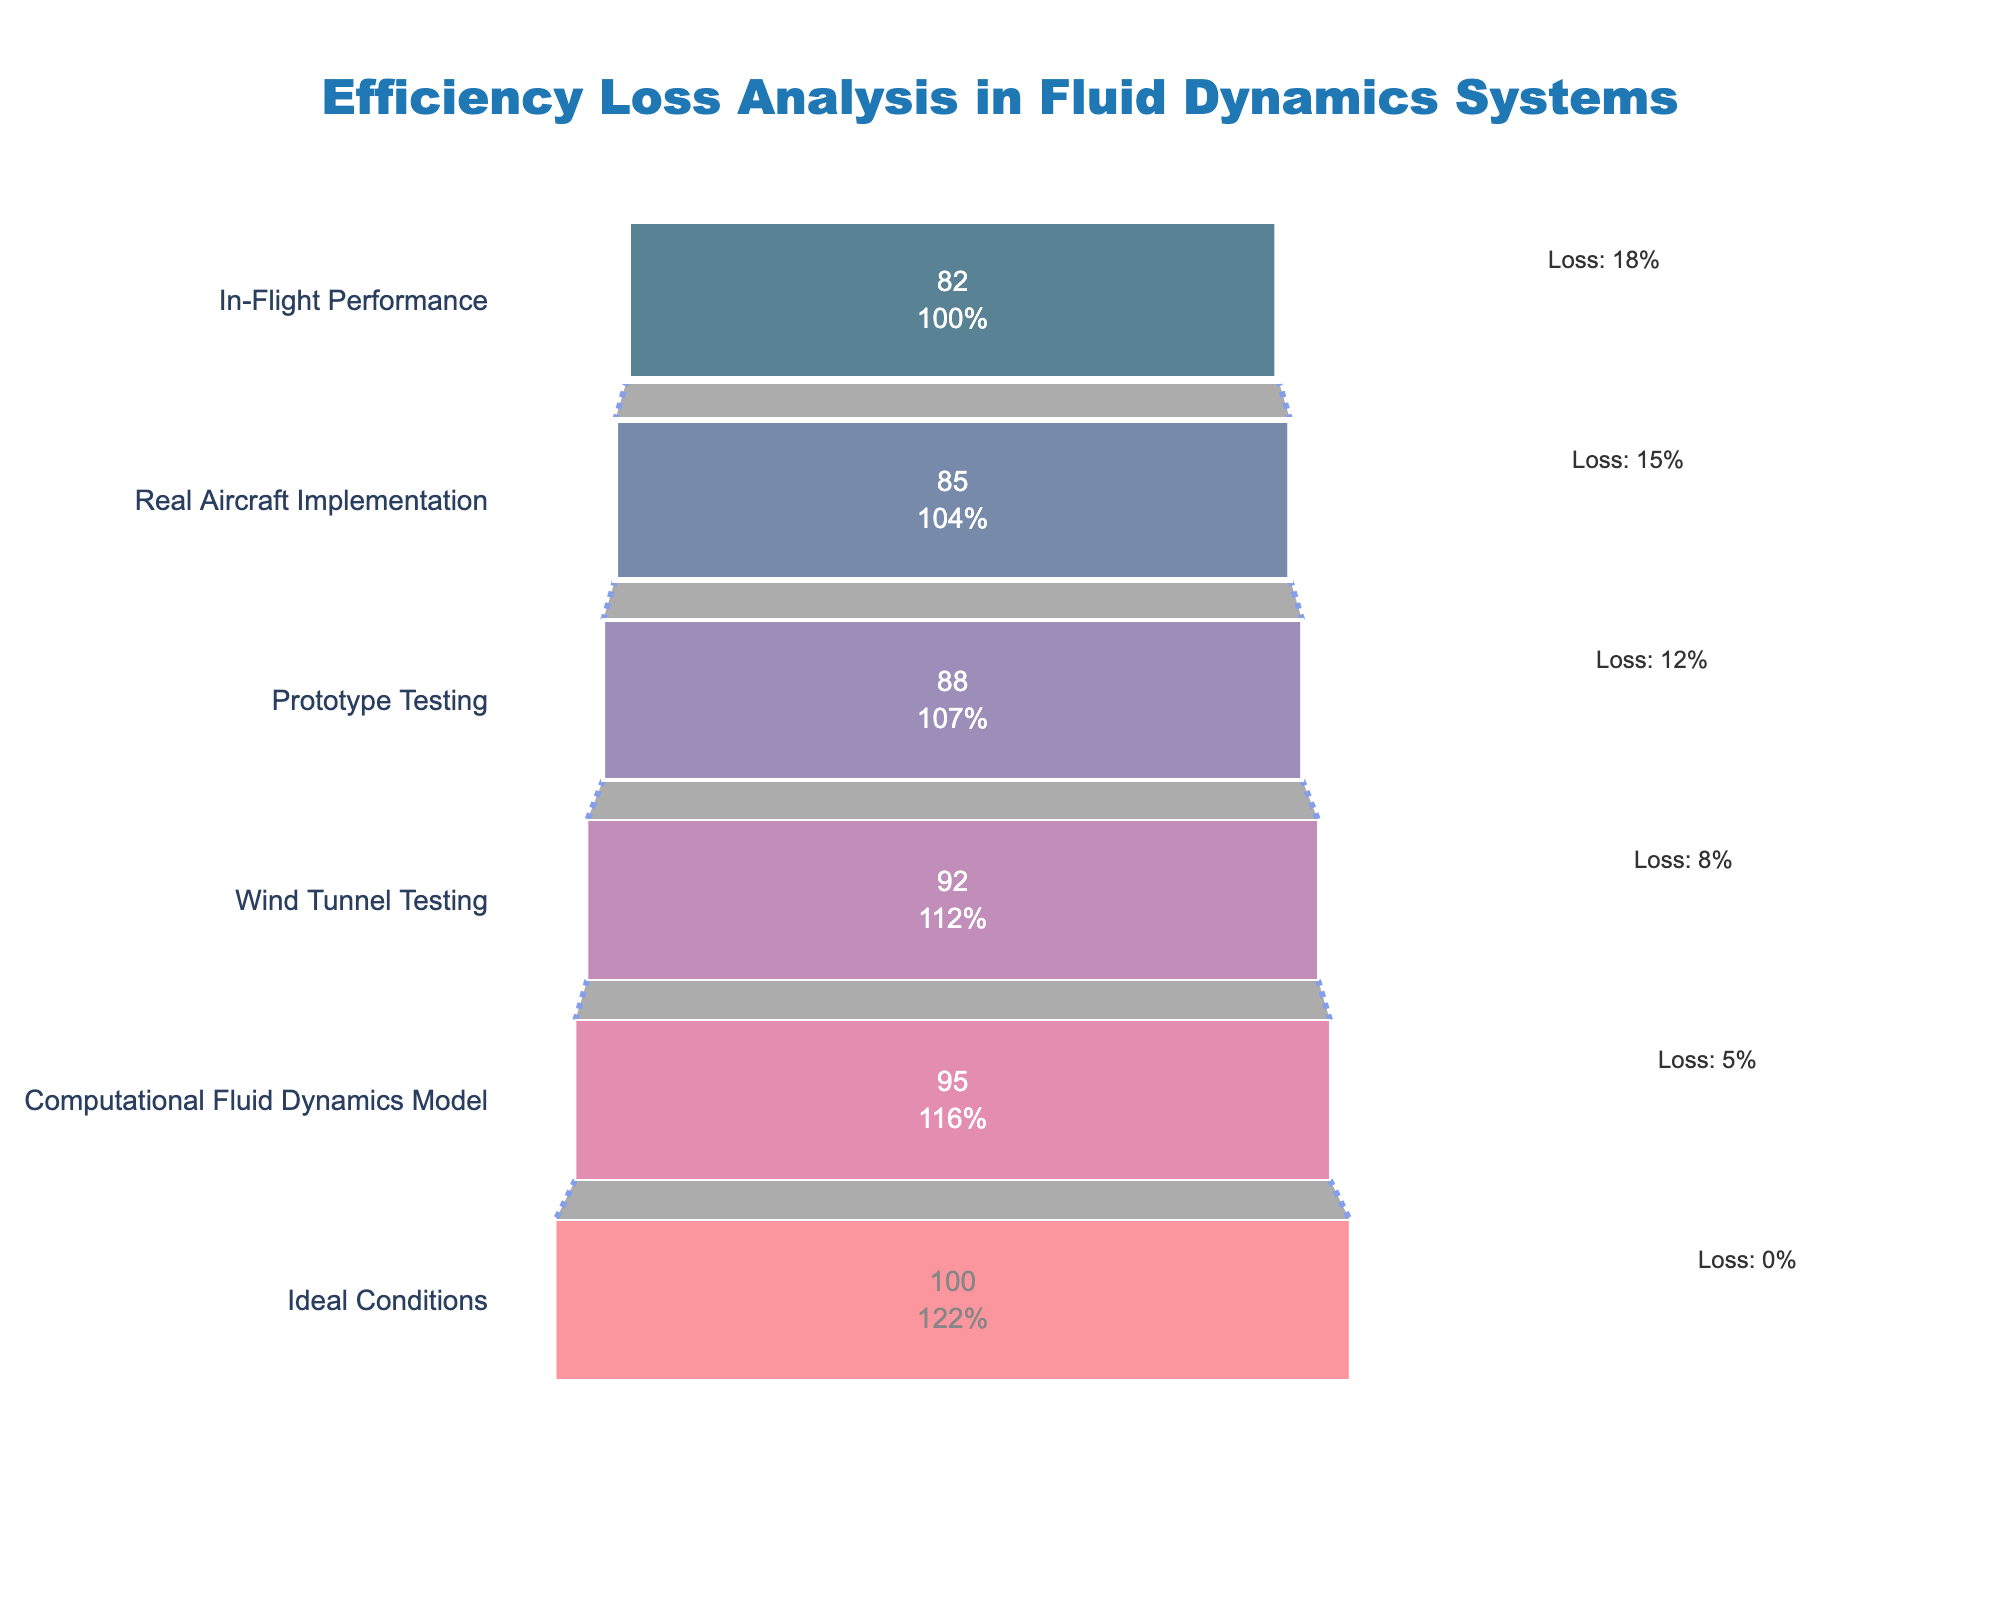What is the title of the chart? The title is located at the top of the chart, which provides a summary or description of what the chart represents.
Answer: Efficiency Loss Analysis in Fluid Dynamics Systems Which stage has the highest efficiency? The highest efficiency is indicated by the largest value on the x-axis and typically appears on the leftmost side or the top of the funnel chart. In this case, 'Ideal Conditions' has the highest efficiency at 100%.
Answer: Ideal Conditions What is the efficiency at the Prototype Testing stage? The specific stage 'Prototype Testing' can be found on the y-axis, and its corresponding efficiency value can be read directly from the x-axis. The efficiency at this stage is 88%.
Answer: 88% How much efficiency is lost during Wind Tunnel Testing compared to the Ideal Conditions? Efficiency loss can be calculated by subtracting the efficiency at the Wind Tunnel Testing stage from the efficiency of the Ideal Conditions. The loss is 100% - 92% = 8%.
Answer: 8% Which stage experiences the most efficiency loss? The stage with the greatest loss will have the largest difference between the Ideal Conditions (100%) and its current efficiency percentage. In the chart, 'In-Flight Performance' has the highest loss at 18%.
Answer: In-Flight Performance What is the average efficiency from Wind Tunnel Testing to In-Flight Performance? First, identify the efficiency values for the stages: Wind Tunnel Testing (92%), Prototype Testing (88%), Real Aircraft Implementation (85%), and In-Flight Performance (82%). Calculate the average: (92 + 88 + 85 + 82) / 4 = 86.75%.
Answer: 86.75% At which stage does the efficiency drop below 90% for the first time? By observing the efficiency percentages starting from the Ideal Conditions, we note when the efficiency first falls below the 90% threshold. This happens at the Prototype Testing stage with 88%.
Answer: Prototype Testing How does the efficiency at Wind Tunnel Testing compare to that at Real Aircraft Implementation? To compare, one should observe both stages and their respective efficiency values on the funnel chart. Wind Tunnel Testing has an efficiency of 92%, whereas Real Aircraft Implementation has 85%.
Answer: Wind Tunnel Testing has higher efficiency than Real Aircraft Implementation What is the total efficiency loss from Ideal Conditions to Real Aircraft Implementation? To find the total loss, subtract the efficiency at Real Aircraft Implementation from the Ideal Conditions: 100% - 85% = 15%.
Answer: 15% How much efficiency is lost between Wind Tunnel Testing and In-Flight Performance? Calculate the drop in efficiency by subtracting the efficiency at In-Flight Performance from that at Wind Tunnel Testing: 92% - 82% = 10%.
Answer: 10% 